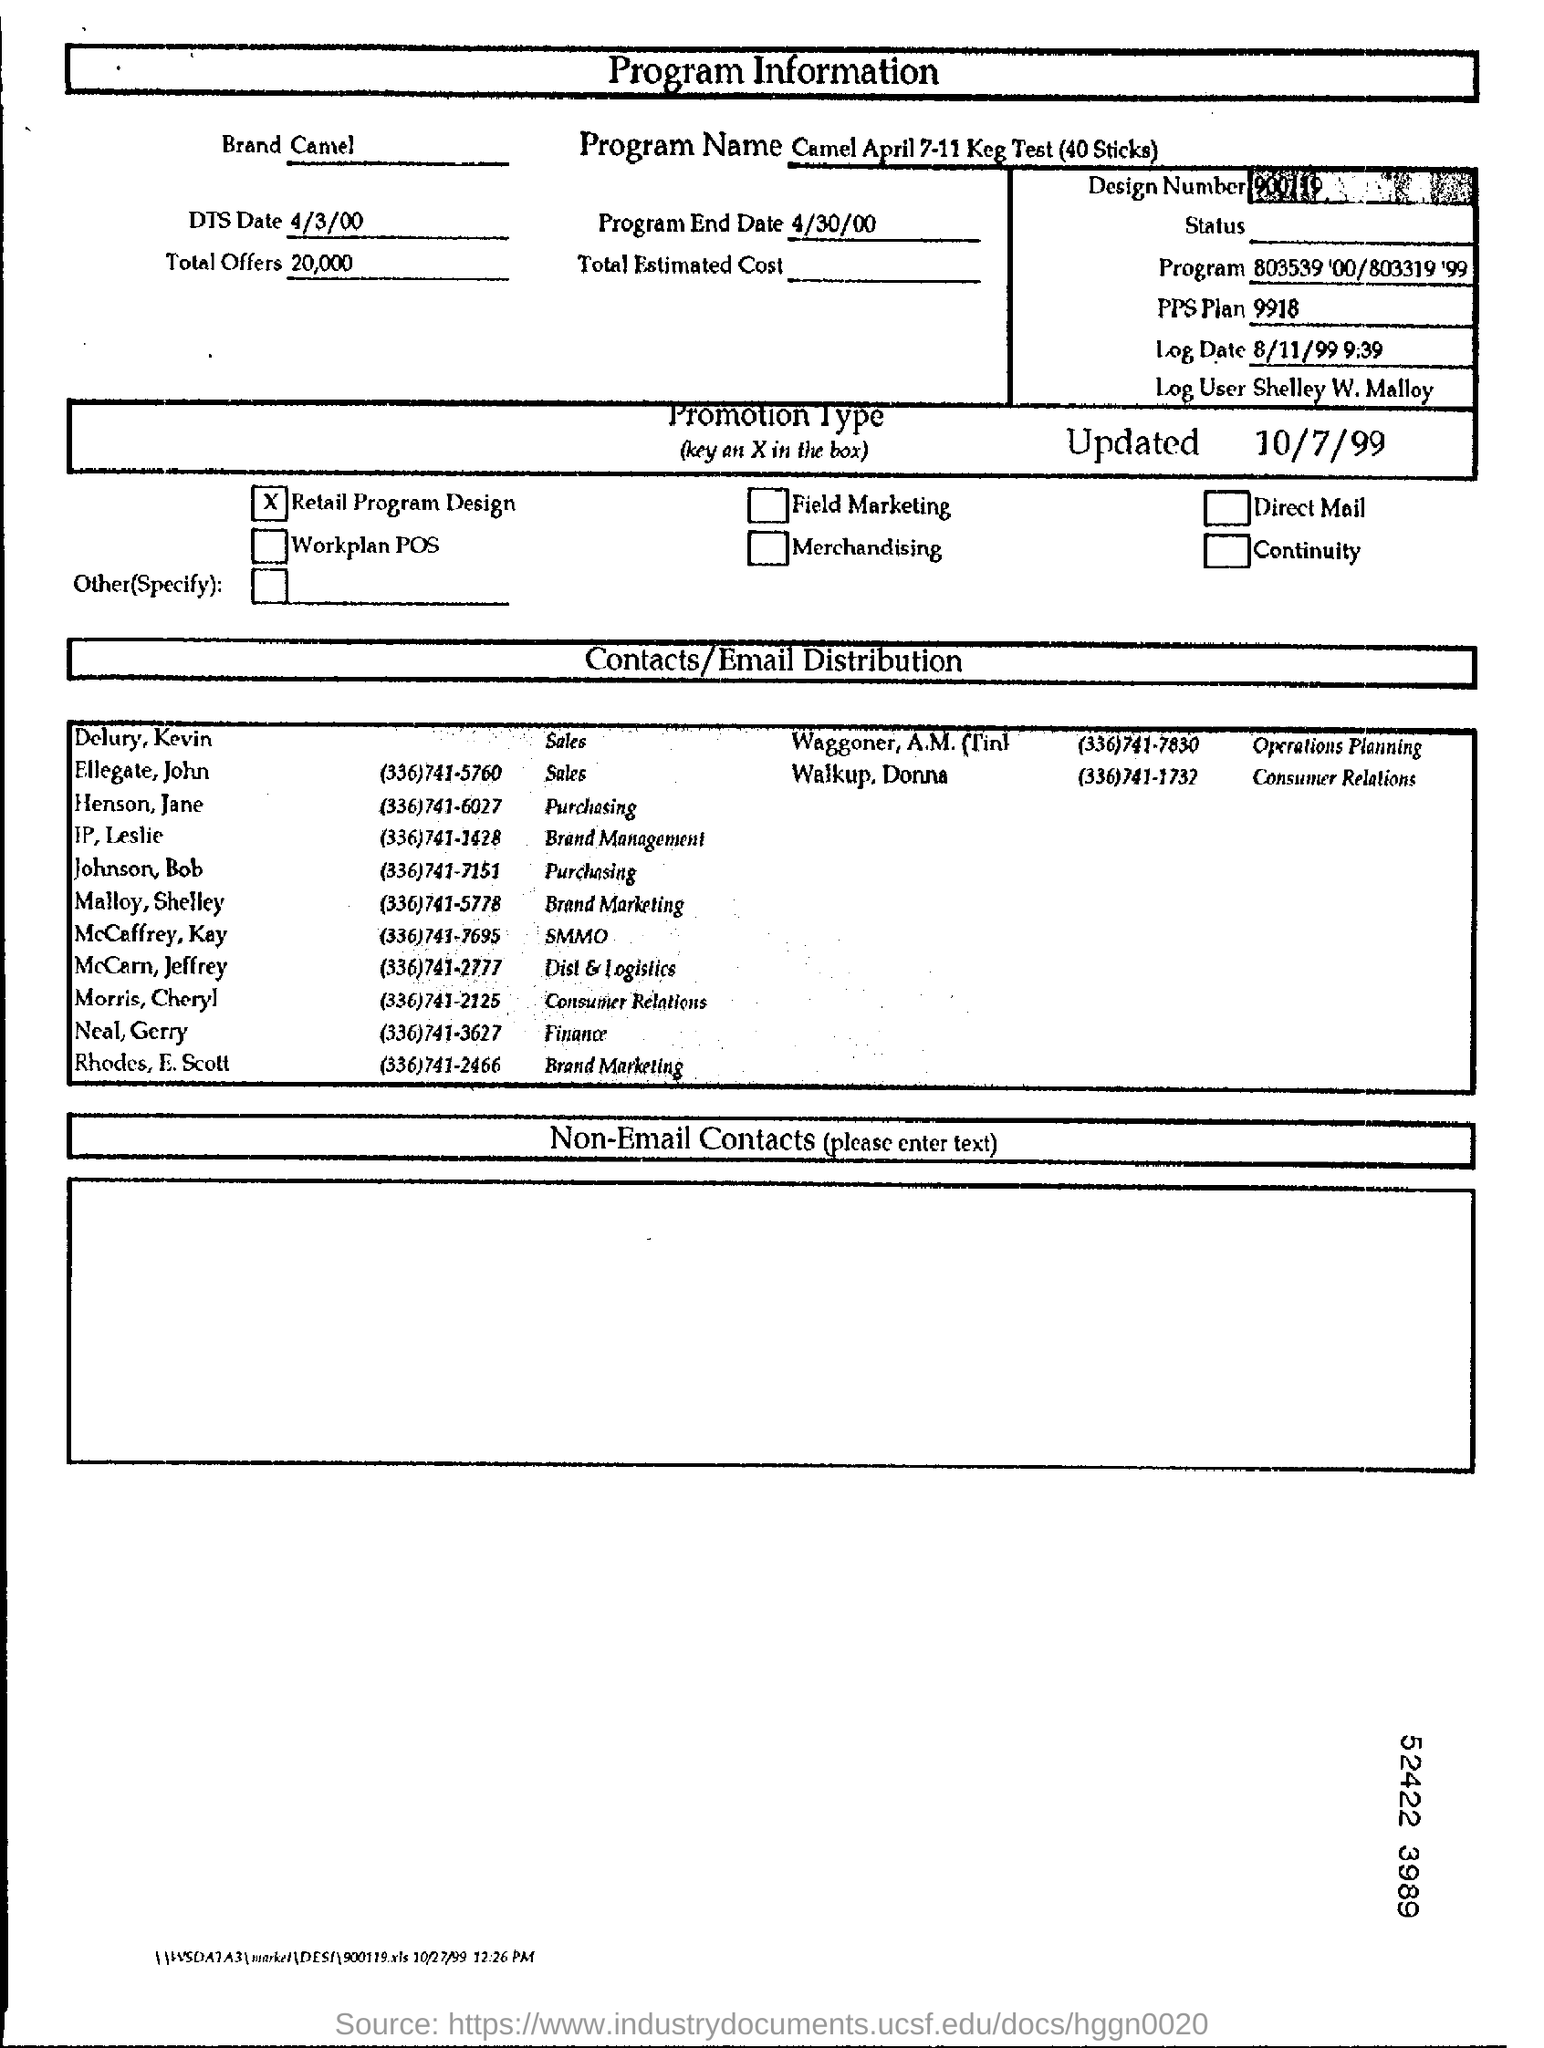Which brand is mentioned?
Your answer should be compact. Camel. What is the program name?
Offer a terse response. Camel April 7-11 Keg Test (40 Sticks). Who is the Log User?
Offer a very short reply. Shelley W. Malloy. When is the program end date?
Ensure brevity in your answer.  4/30/00. Who is doing Consumer Relations?
Offer a very short reply. Morris, Cheryl. What is the contact number of Jane Henson?
Provide a short and direct response. (336)741-6027. What is the promotion type?
Provide a succinct answer. Retail Program Design. When was the form updated?
Your answer should be very brief. 10/7/99. 